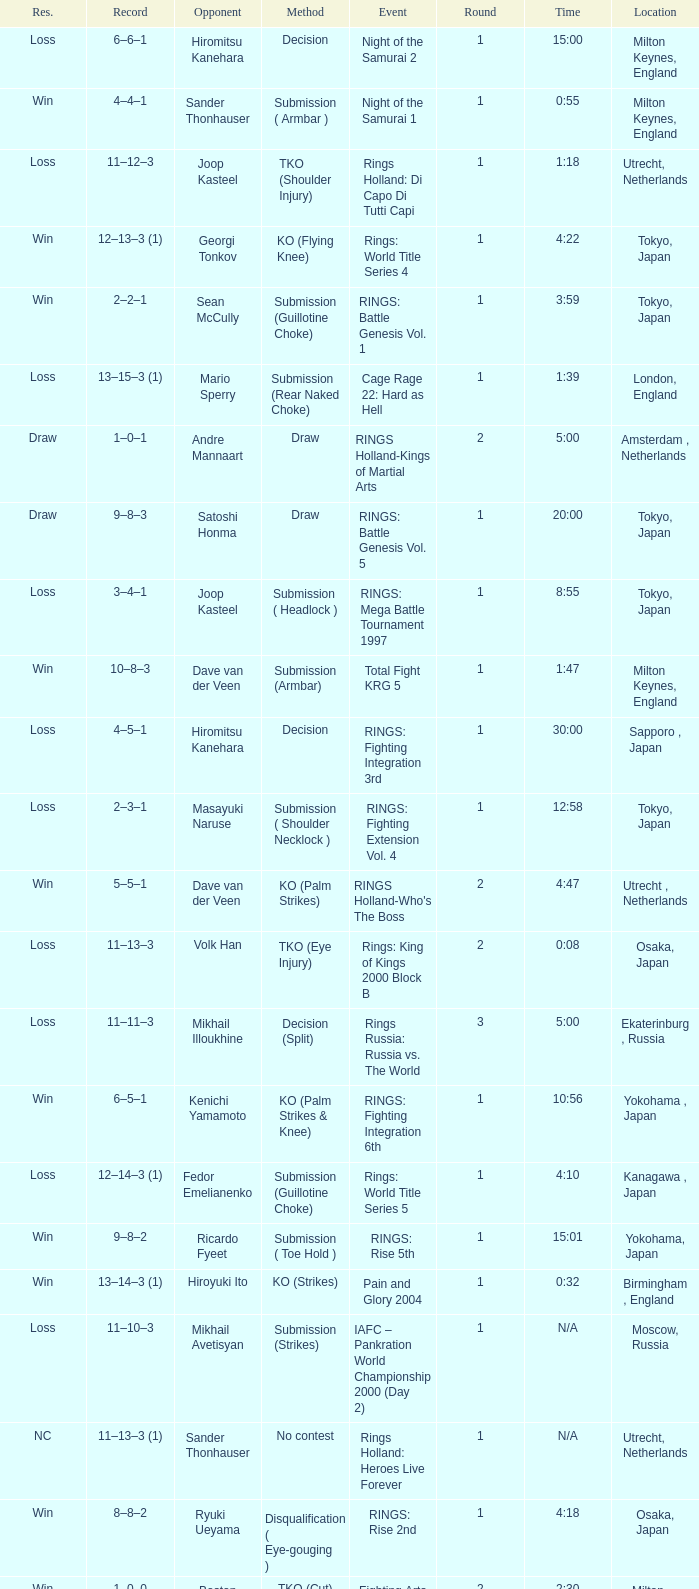What was the method for opponent of Ivan Serati? Submission (Rear Naked Choke). 